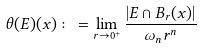Convert formula to latex. <formula><loc_0><loc_0><loc_500><loc_500>\theta ( E ) ( x ) \colon = \lim _ { r \to 0 ^ { + } } \frac { | E \cap B _ { r } ( x ) | } { \omega _ { n } r ^ { n } }</formula> 